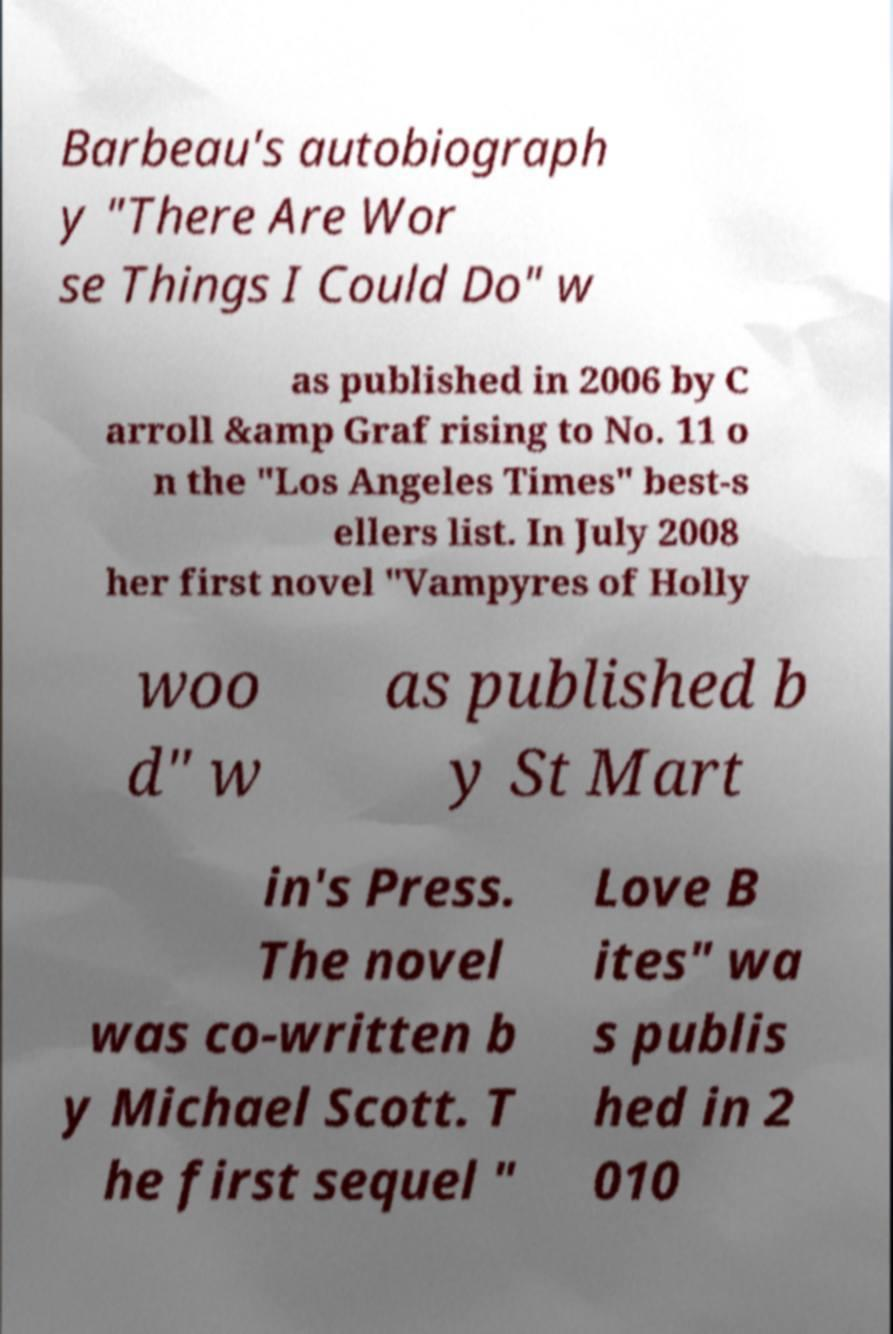For documentation purposes, I need the text within this image transcribed. Could you provide that? Barbeau's autobiograph y "There Are Wor se Things I Could Do" w as published in 2006 by C arroll &amp Graf rising to No. 11 o n the "Los Angeles Times" best-s ellers list. In July 2008 her first novel "Vampyres of Holly woo d" w as published b y St Mart in's Press. The novel was co-written b y Michael Scott. T he first sequel " Love B ites" wa s publis hed in 2 010 